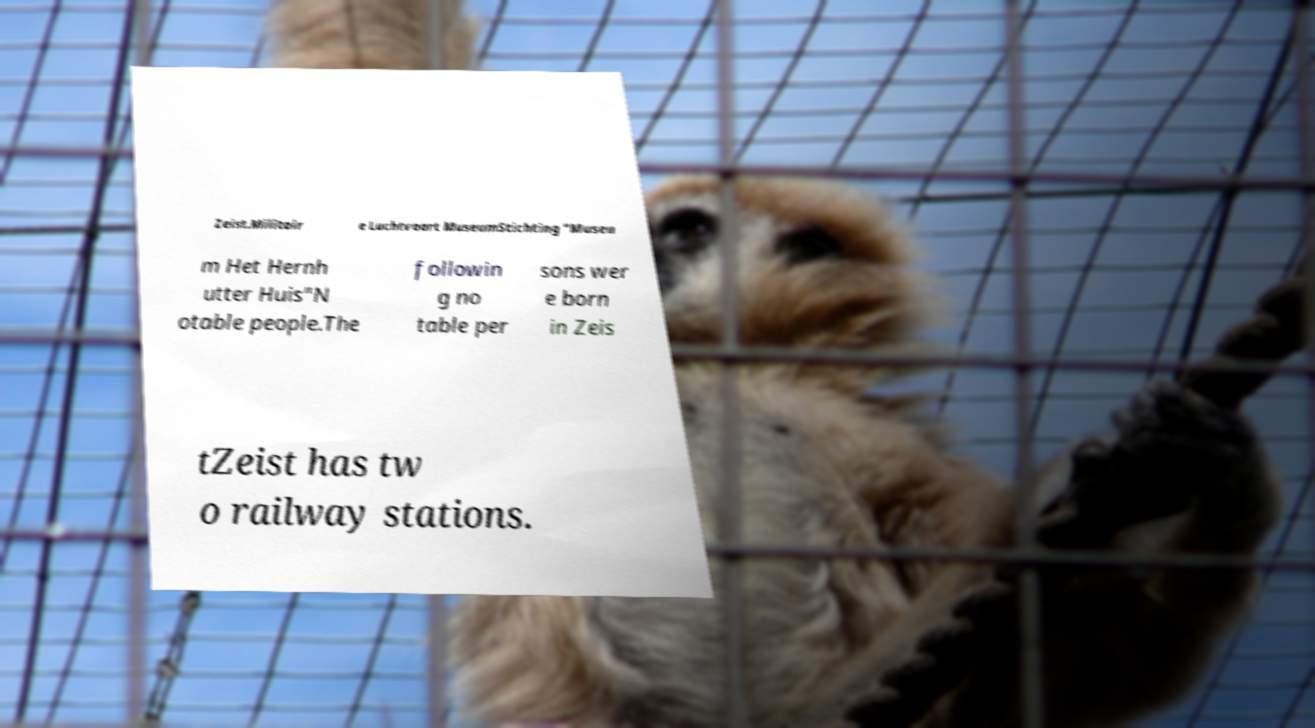Please read and relay the text visible in this image. What does it say? Zeist.Militair e Luchtvaart MuseumStichting "Museu m Het Hernh utter Huis"N otable people.The followin g no table per sons wer e born in Zeis tZeist has tw o railway stations. 